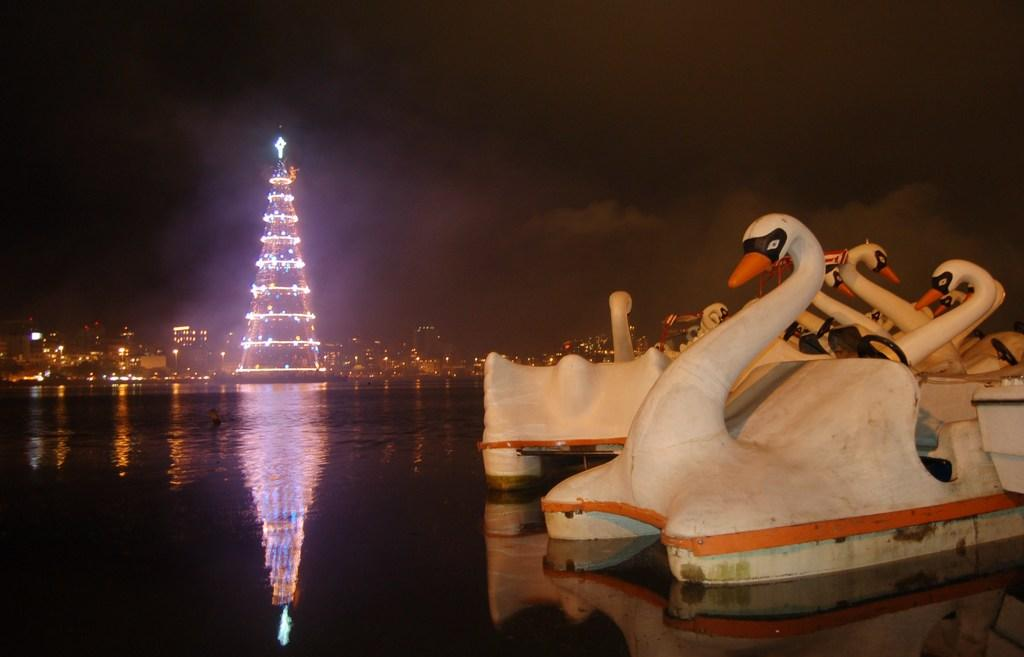What type of vehicles can be seen on the right side of the image? There are boats on the right side of the image. What body of water is visible in the image? There is a river visible at the bottom of the image. What structures can be seen in the background of the image? There are buildings and a tower in the background of the image. What part of the natural environment is visible in the image? The sky is visible in the background of the image. What health benefits can be gained from the force of the river in the image? There are no health benefits mentioned or implied in the image, as it primarily features boats, a river, and buildings in the background. 